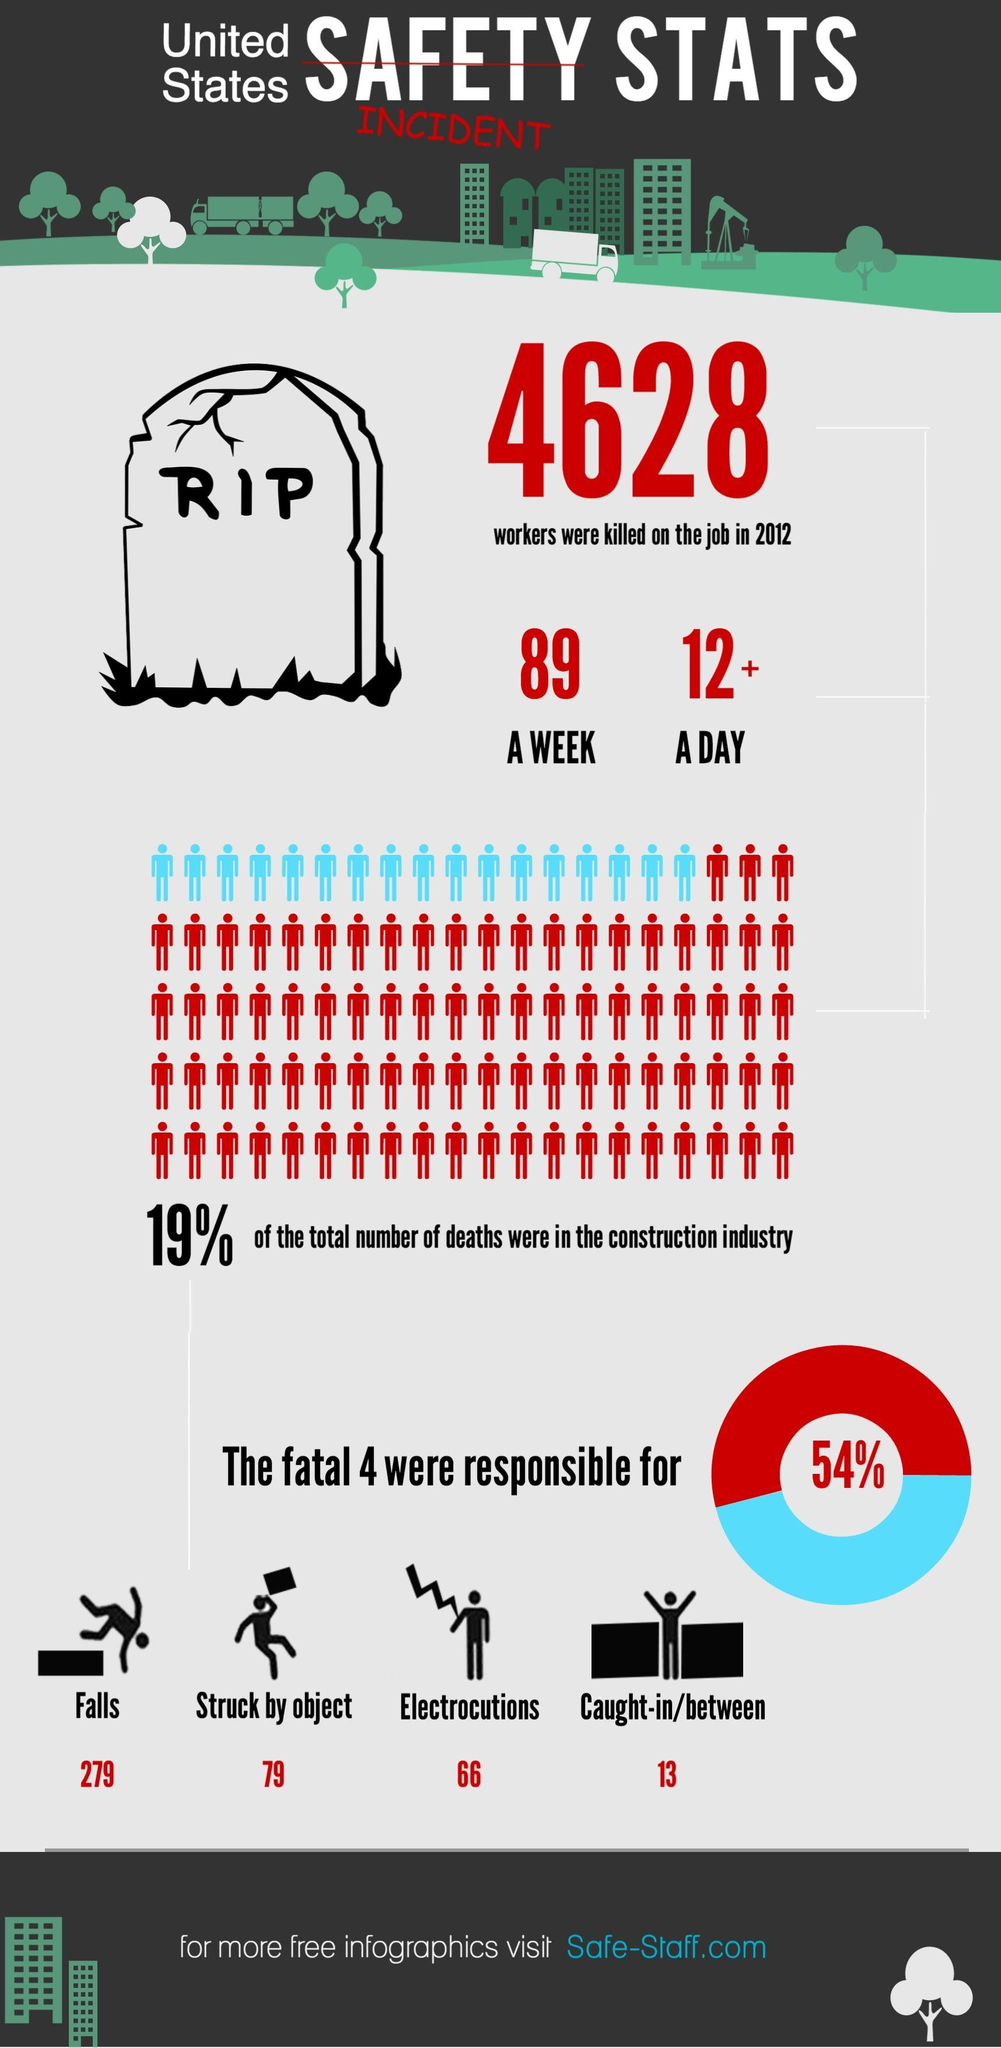List a handful of essential elements in this visual. Last week, a total of 89 workers were killed. In the United States, an average of 279 workers are killed each year as a result of falls, according to recent data. Eighty-one percent of all deaths among workers were not in the construction field. On average, 12 workers are killed in a day due to work-related accidents. Seventy-nine workers were struck by an object. 